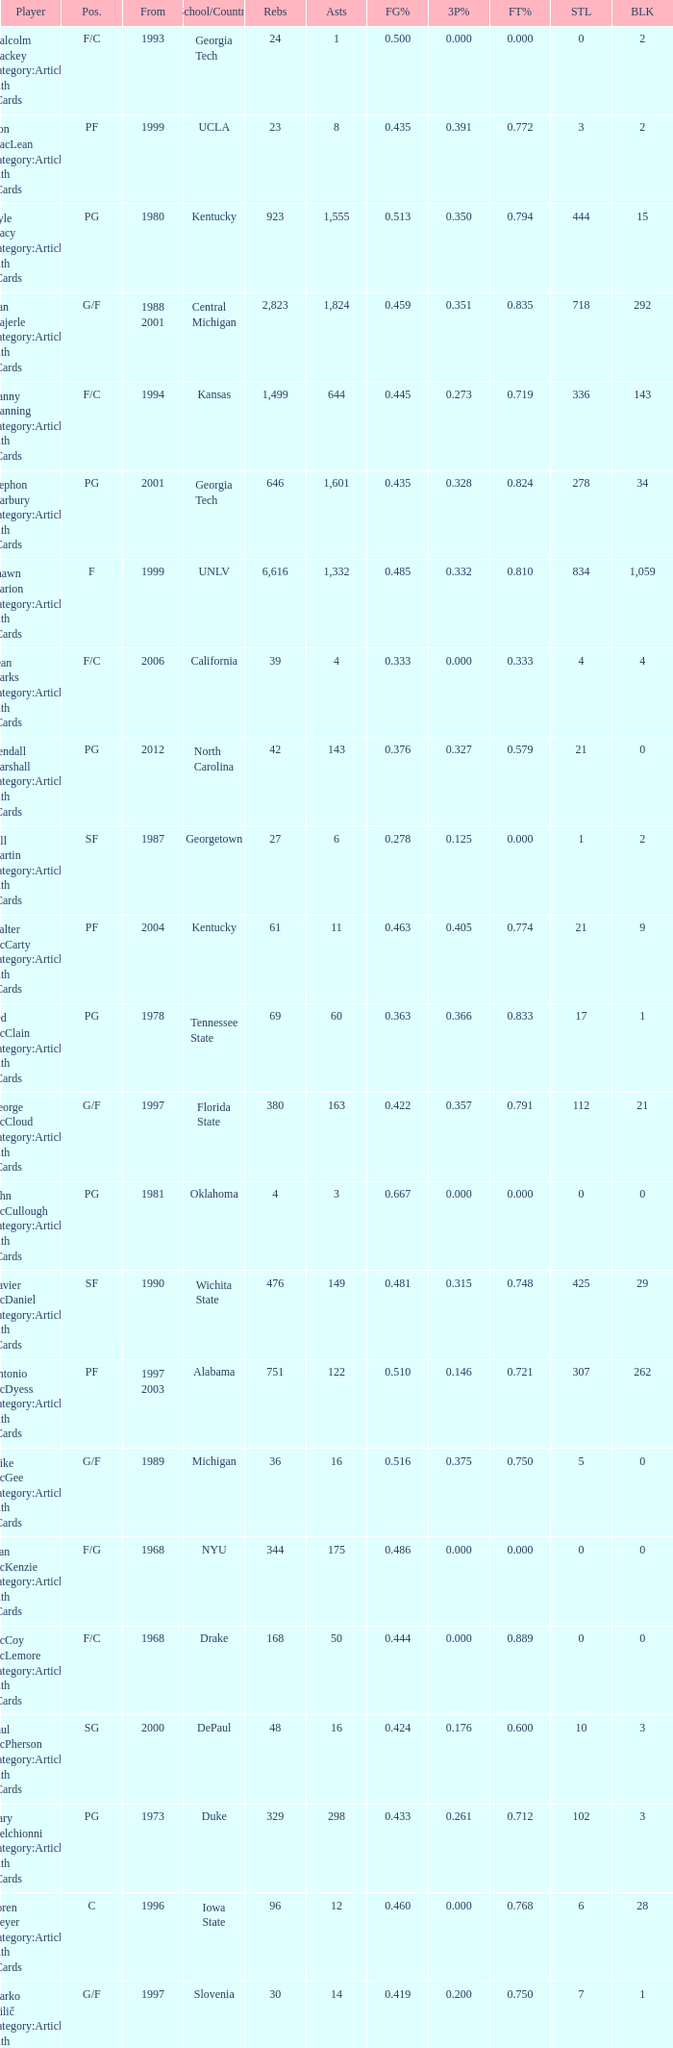Who has the high assists in 2000? 16.0. 